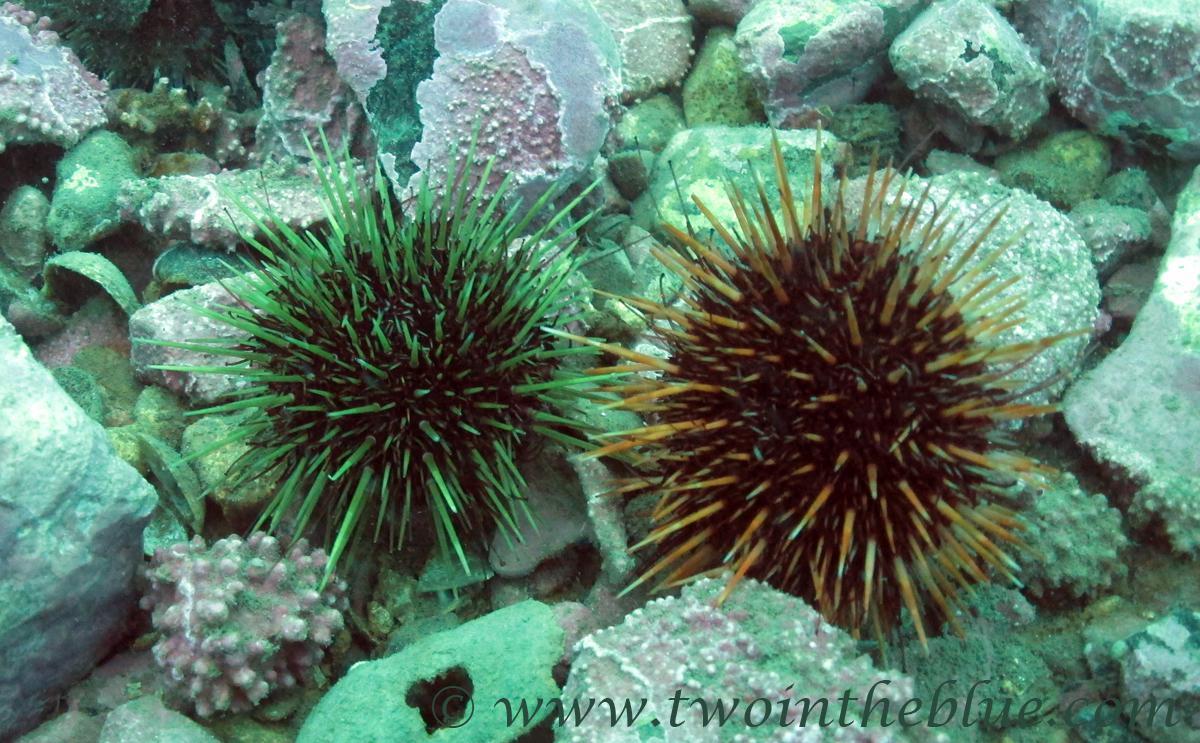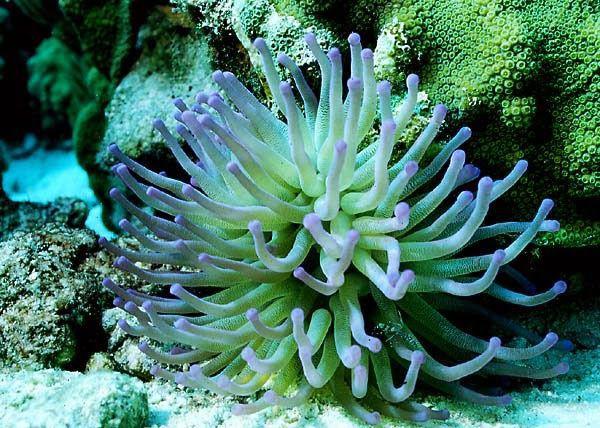The first image is the image on the left, the second image is the image on the right. Analyze the images presented: Is the assertion "The left image contains a green and purple anemone, while the right has a green one." valid? Answer yes or no. No. The first image is the image on the left, the second image is the image on the right. Considering the images on both sides, is "One image shows a flower-like anemone with mint green tendrils and a darker yellowish center with a visible slit in it." valid? Answer yes or no. No. 